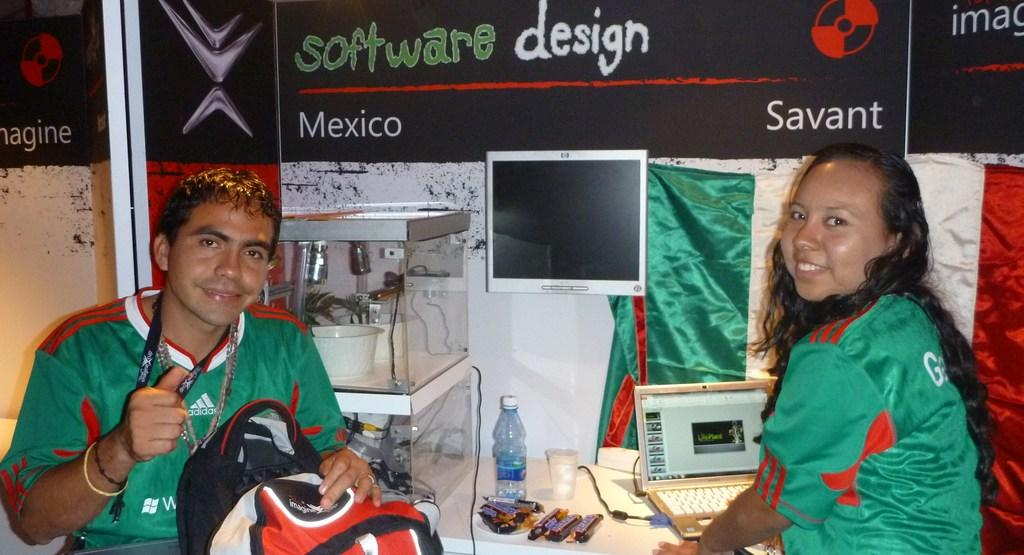<image>
Render a clear and concise summary of the photo. Two people wearing green shirts sit under a software design poster. 